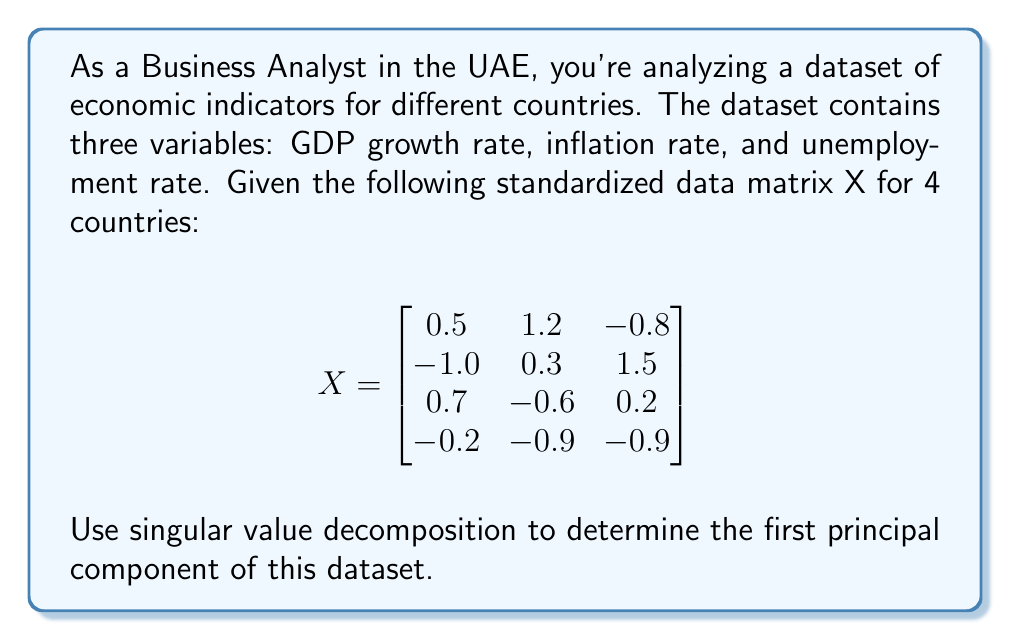Can you answer this question? To determine the first principal component using singular value decomposition (SVD), we'll follow these steps:

1) The SVD of matrix X is given by $X = U\Sigma V^T$, where U and V are orthogonal matrices and $\Sigma$ is a diagonal matrix of singular values.

2) We need to compute $X^TX$:

   $$X^TX = \begin{bmatrix}
   0.5 & -1.0 & 0.7 & -0.2 \\
   1.2 & 0.3 & -0.6 & -0.9 \\
   -0.8 & 1.5 & 0.2 & -0.9
   \end{bmatrix} \begin{bmatrix}
   0.5 & 1.2 & -0.8 \\
   -1.0 & 0.3 & 1.5 \\
   0.7 & -0.6 & 0.2 \\
   -0.2 & -0.9 & -0.9
   \end{bmatrix}$$

   $$X^TX = \begin{bmatrix}
   2.54 & -0.54 & -1.97 \\
   -0.54 & 3.30 & 0.18 \\
   -1.97 & 0.18 & 3.74
   \end{bmatrix}$$

3) The eigenvalues of $X^TX$ are the squares of the singular values of X. We need to find the largest eigenvalue and its corresponding eigenvector.

4) Using a numerical method or software, we can determine that the largest eigenvalue is approximately 5.8416, and its corresponding normalized eigenvector is:

   $$v_1 \approx \begin{bmatrix}
   -0.5176 \\
   0.2634 \\
   0.8145
   \end{bmatrix}$$

5) This eigenvector $v_1$ represents the loadings of the first principal component.

6) The first principal component is given by $Xv_1$, which represents a linear combination of the original variables that captures the most variance in the data.

Therefore, the first principal component is:

$$PC_1 = -0.5176 \cdot (\text{GDP growth}) + 0.2634 \cdot (\text{Inflation}) + 0.8145 \cdot (\text{Unemployment})$$
Answer: $PC_1 = -0.5176 \cdot (\text{GDP growth}) + 0.2634 \cdot (\text{Inflation}) + 0.8145 \cdot (\text{Unemployment})$ 